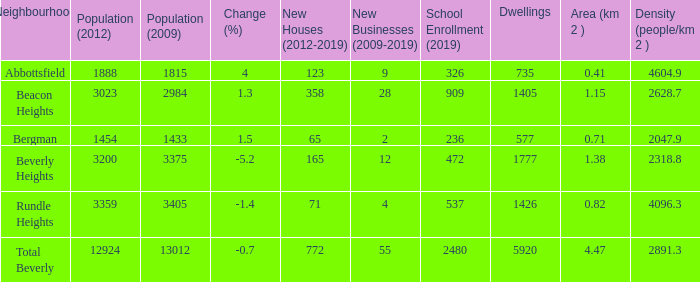What is the density of a zone that is 0.0. 